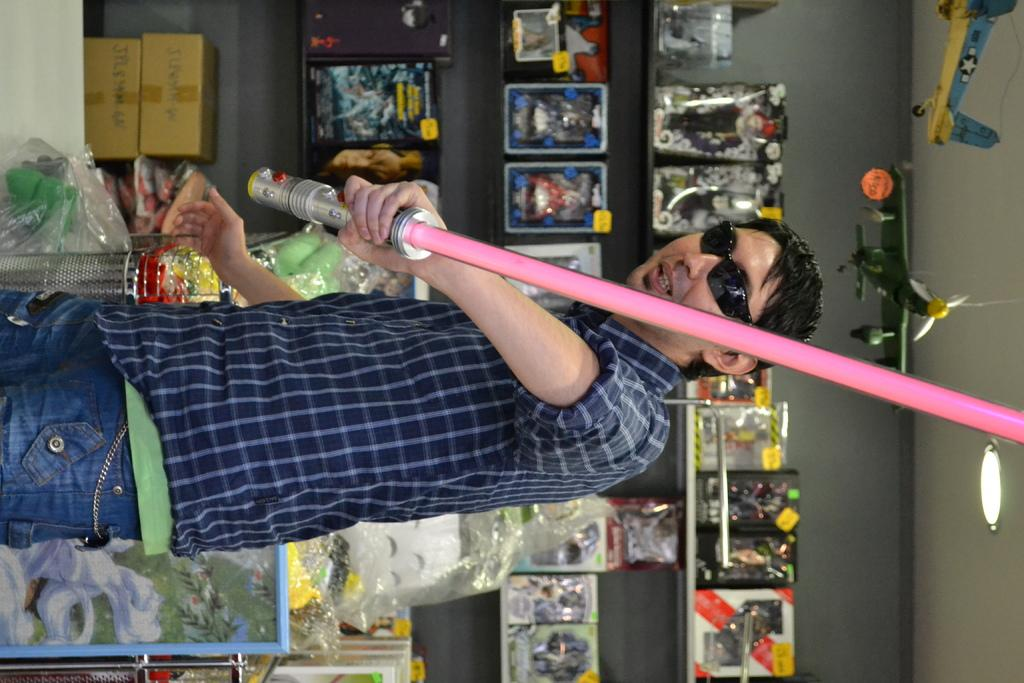What is the man in the image doing? The man is standing in the image. What is the man holding in the image? The man is holding a stick. What can be seen in the background of the image? There is a wall visible in the image. What type of lighting is present in the image? Ceiling lights are present in the image. What is depicted on the wall in the image? There are aeroplanes depicted on the wall. What objects are on the shelves in the image? There are boxes on the shelves in the image. What type of curtain is hanging in front of the aeroplanes on the wall? There is no curtain present in the image; only the wall with aeroplanes is visible. Is the man in the image sleeping? The man is standing in the image, not sleeping. 